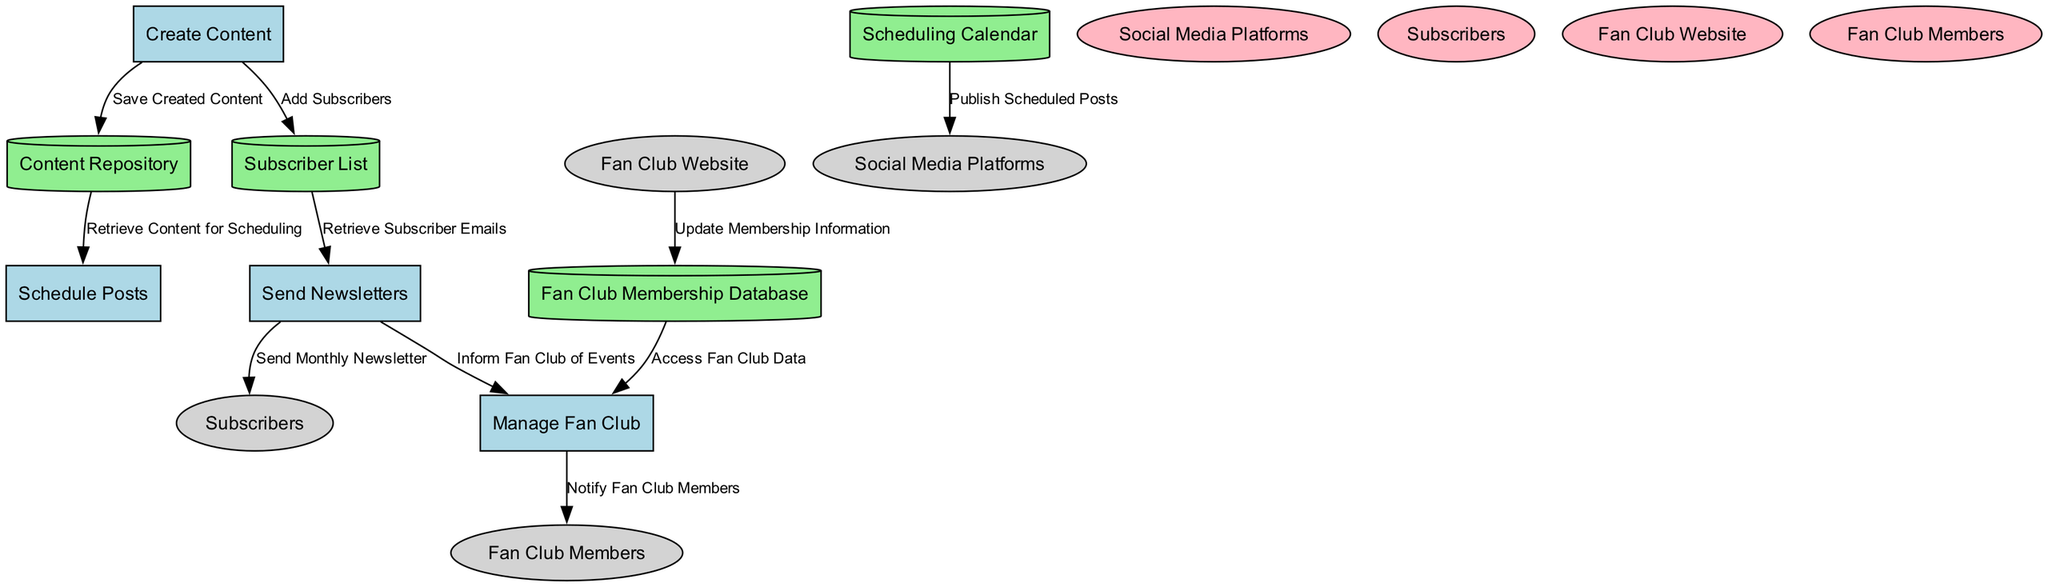What are the names of the data stores in the diagram? The diagram includes four data stores: Content Repository, Scheduling Calendar, Subscriber List, and Fan Club Membership Database.
Answer: Content Repository, Scheduling Calendar, Subscriber List, Fan Club Membership Database How many processes are represented in the diagram? There are four processes in total: Create Content, Schedule Posts, Send Newsletters, and Manage Fan Club.
Answer: 4 Which process is responsible for sending the monthly newsletter? The process labeled Send Newsletters is designated to send the monthly newsletter to subscribers.
Answer: Send Newsletters What is the source of the data flow labeled "Notify Fan Club Members"? The data flow "Notify Fan Club Members" originates from the process Manage Fan Club.
Answer: Manage Fan Club How do subscribers receive information about events? Subscribers receive information about events through the process that informs the fan club of events after retrieving subscriber emails from the Subscriber List.
Answer: By sending a newsletter from Send Newsletters What type of entity is the Social Media Platforms in the diagram? Social Media Platforms are classified as an external entity represented by an ellipse in the diagram.
Answer: External entity Which data store is accessed by the Manage Fan Club process? The Manage Fan Club process accesses the Fan Club Membership Database to retrieve relevant fan club data.
Answer: Fan Club Membership Database What happens to the created content after it is produced? The created content is saved into the Content Repository for future use and scheduling of posts.
Answer: It is saved in the Content Repository How many edges are used to represent data flows in the diagram? The diagram features ten distinct data flows connecting different processes, external entities, and data stores.
Answer: 10 Which data store is updated with membership information? Membership information is updated in the Fan Club Membership Database, sourced from the Fan Club Website.
Answer: Fan Club Membership Database 